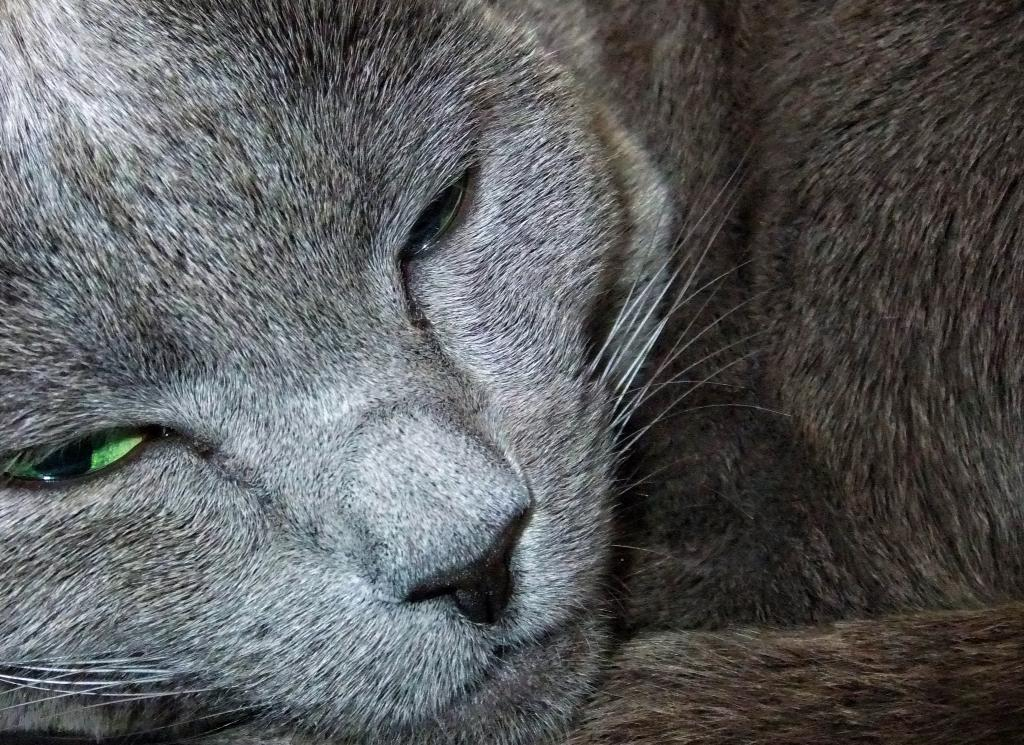What type of creature is present in the image? There is an animal in the image. What color is the animal? The animal has a grey color. What color are the animal's eyes? The animal's eyes are green. How many apples can be seen in the image? There are no apples present in the image. What type of horse is depicted in the image? There is no horse present in the image; it features an animal with grey color and green eyes. 